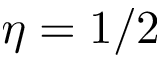<formula> <loc_0><loc_0><loc_500><loc_500>\eta = 1 / 2</formula> 